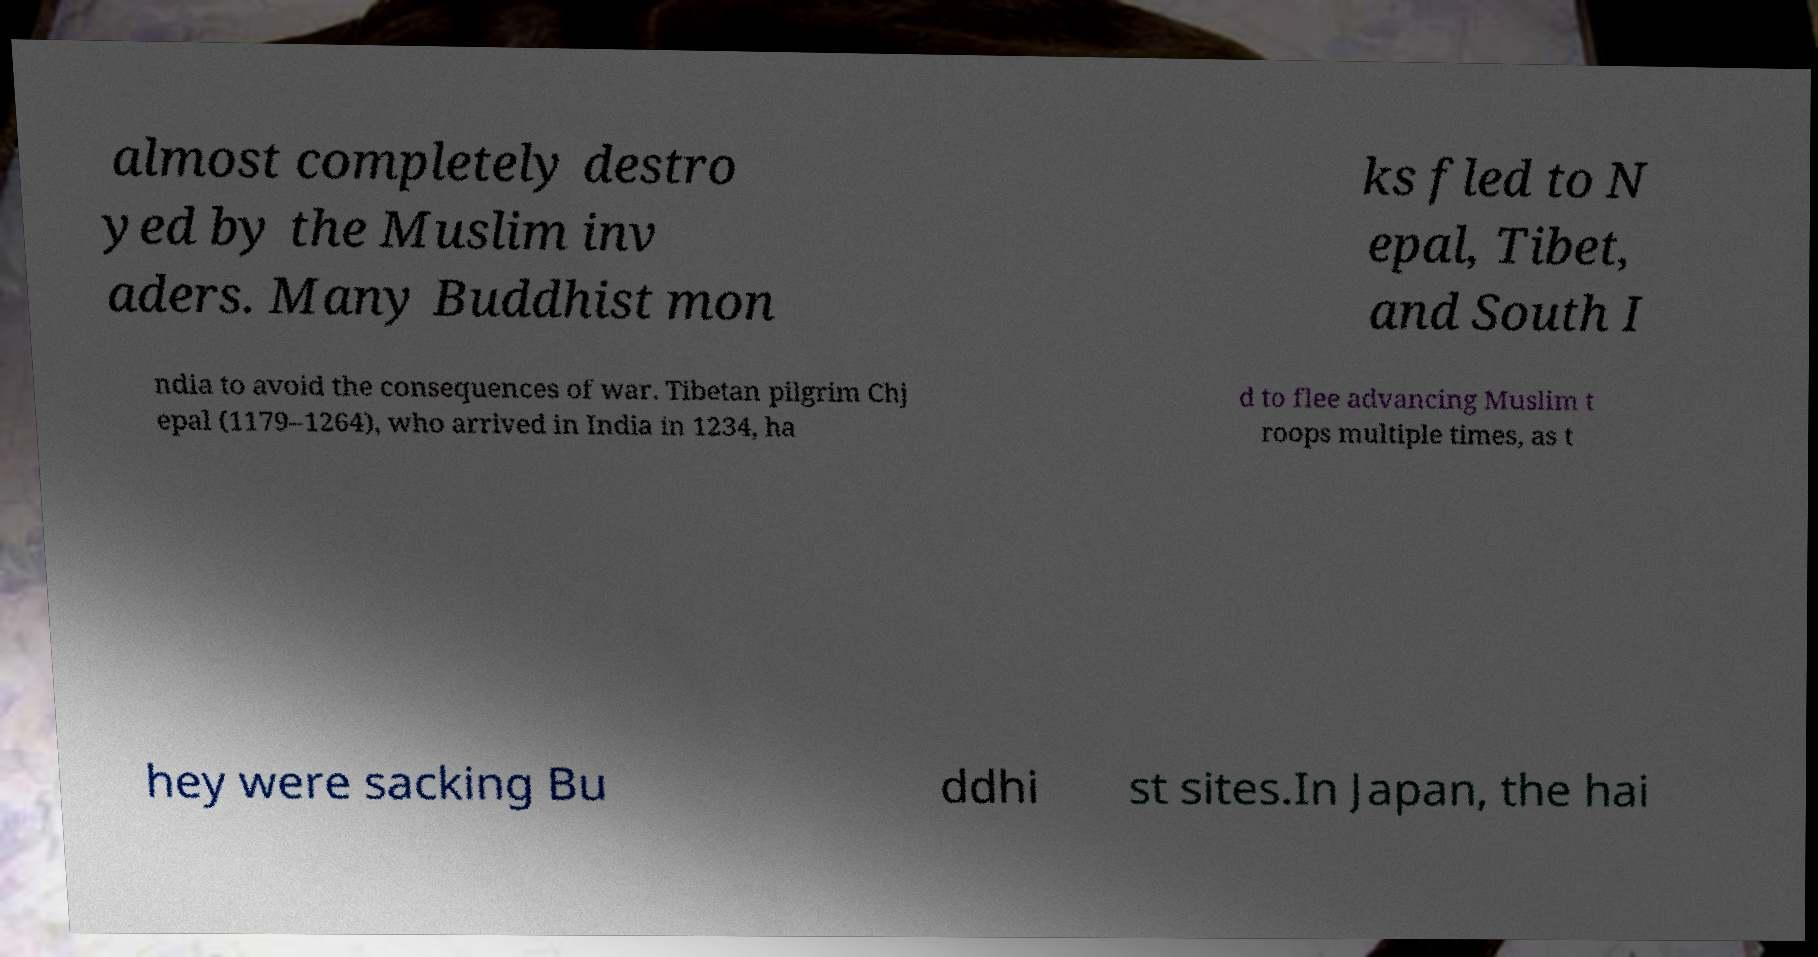Could you assist in decoding the text presented in this image and type it out clearly? almost completely destro yed by the Muslim inv aders. Many Buddhist mon ks fled to N epal, Tibet, and South I ndia to avoid the consequences of war. Tibetan pilgrim Chj epal (1179–1264), who arrived in India in 1234, ha d to flee advancing Muslim t roops multiple times, as t hey were sacking Bu ddhi st sites.In Japan, the hai 